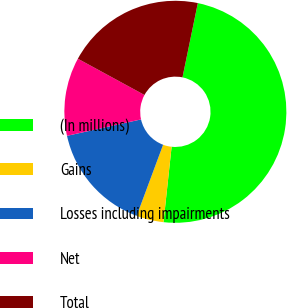Convert chart. <chart><loc_0><loc_0><loc_500><loc_500><pie_chart><fcel>(In millions)<fcel>Gains<fcel>Losses including impairments<fcel>Net<fcel>Total<nl><fcel>48.46%<fcel>3.96%<fcel>15.86%<fcel>11.41%<fcel>20.31%<nl></chart> 